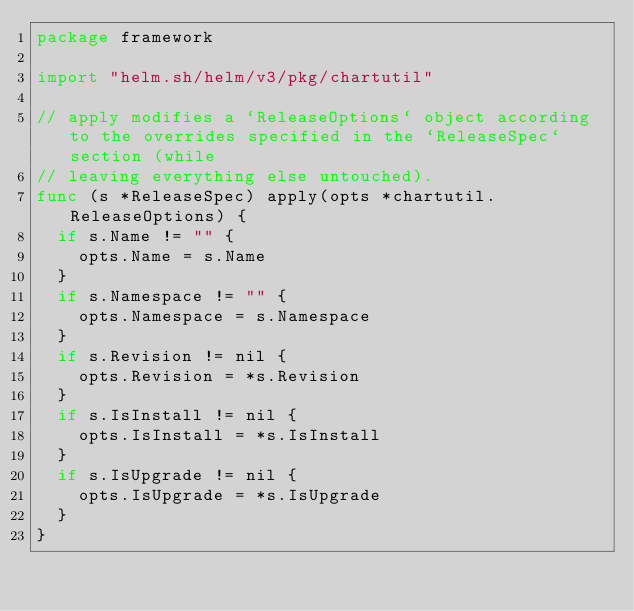<code> <loc_0><loc_0><loc_500><loc_500><_Go_>package framework

import "helm.sh/helm/v3/pkg/chartutil"

// apply modifies a `ReleaseOptions` object according to the overrides specified in the `ReleaseSpec` section (while
// leaving everything else untouched).
func (s *ReleaseSpec) apply(opts *chartutil.ReleaseOptions) {
	if s.Name != "" {
		opts.Name = s.Name
	}
	if s.Namespace != "" {
		opts.Namespace = s.Namespace
	}
	if s.Revision != nil {
		opts.Revision = *s.Revision
	}
	if s.IsInstall != nil {
		opts.IsInstall = *s.IsInstall
	}
	if s.IsUpgrade != nil {
		opts.IsUpgrade = *s.IsUpgrade
	}
}
</code> 